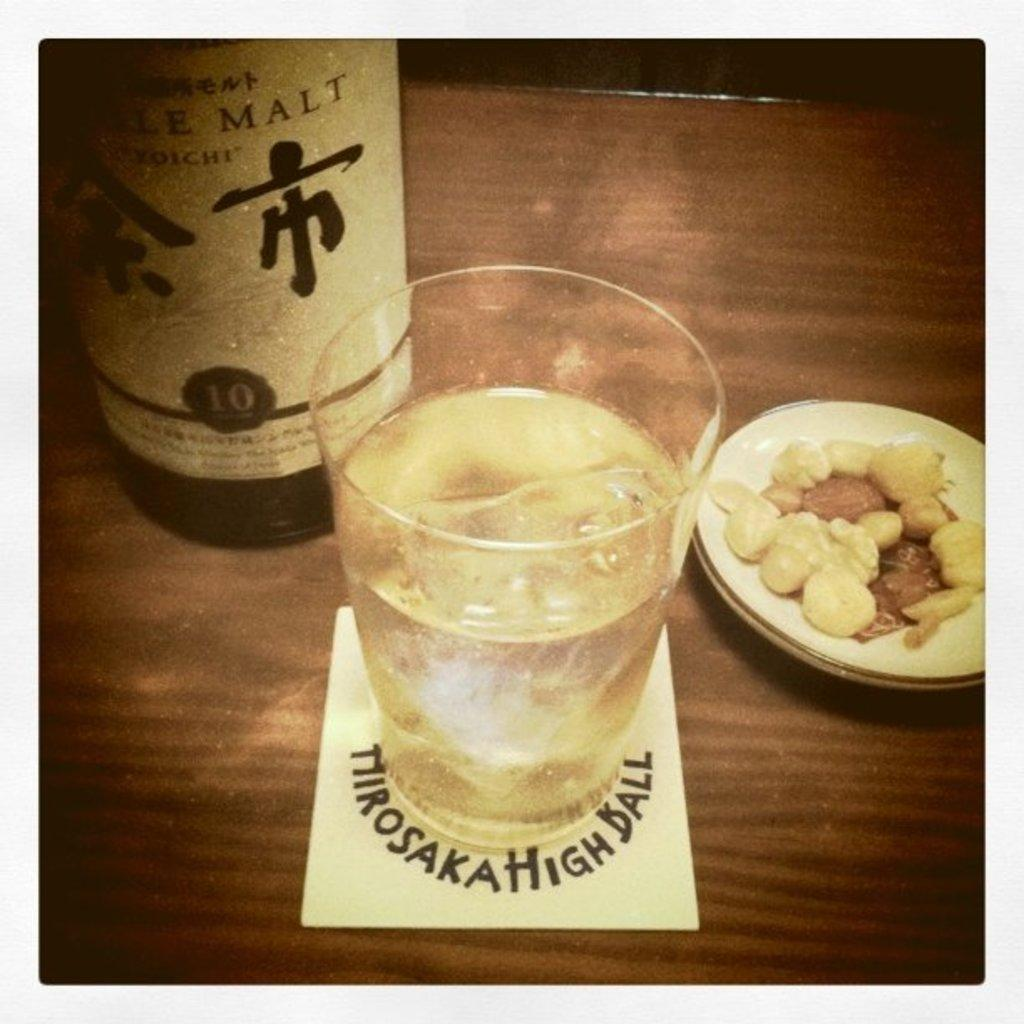<image>
Share a concise interpretation of the image provided. A bottle of wine and a glass sitting on coaster reading tiirosaka high ball 